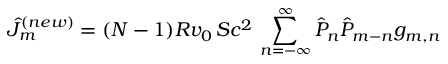<formula> <loc_0><loc_0><loc_500><loc_500>\hat { J } _ { m } ^ { ( n e w ) } = ( N - 1 ) R v _ { 0 } \, S c ^ { 2 } \, \sum _ { n = - \infty } ^ { \infty } \hat { P } _ { n } \hat { P } _ { m - n } g _ { m , n }</formula> 